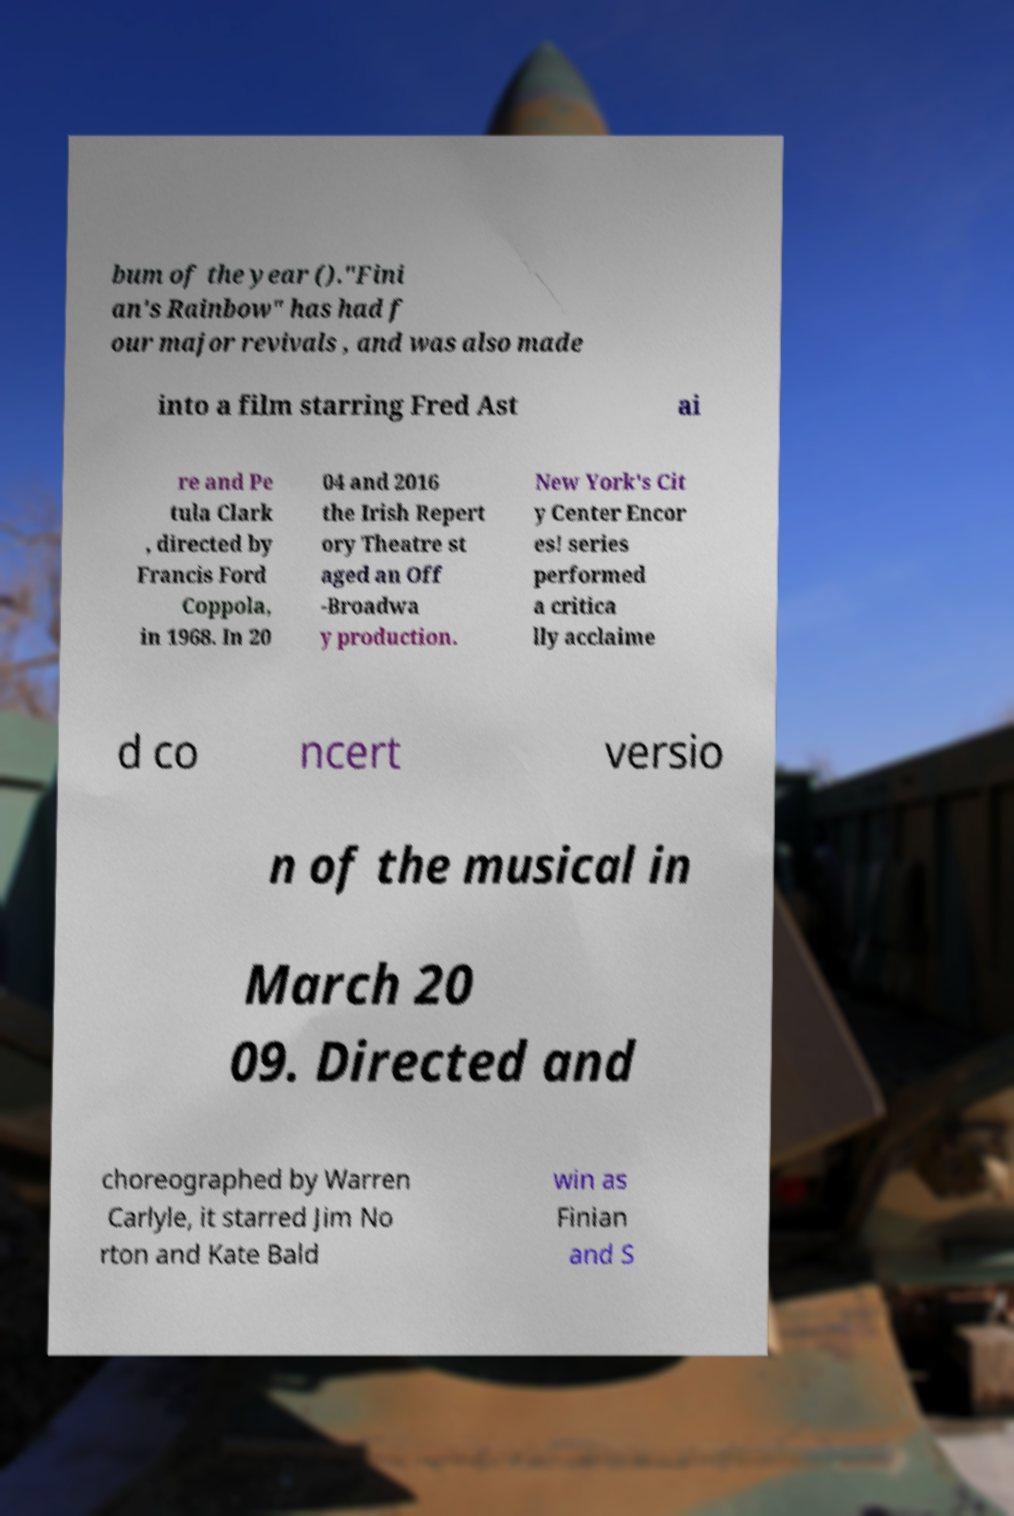I need the written content from this picture converted into text. Can you do that? bum of the year ()."Fini an's Rainbow" has had f our major revivals , and was also made into a film starring Fred Ast ai re and Pe tula Clark , directed by Francis Ford Coppola, in 1968. In 20 04 and 2016 the Irish Repert ory Theatre st aged an Off -Broadwa y production. New York's Cit y Center Encor es! series performed a critica lly acclaime d co ncert versio n of the musical in March 20 09. Directed and choreographed by Warren Carlyle, it starred Jim No rton and Kate Bald win as Finian and S 